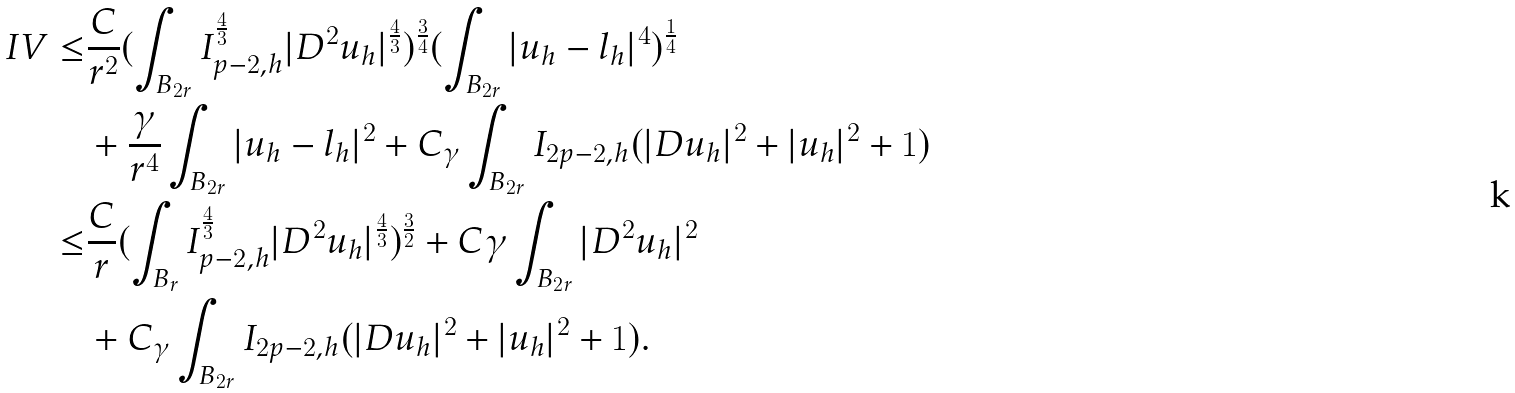<formula> <loc_0><loc_0><loc_500><loc_500>I V \leq & \frac { C } { r ^ { 2 } } ( \int _ { B _ { 2 r } } I _ { p - 2 , h } ^ { \frac { 4 } { 3 } } | D ^ { 2 } u _ { h } | ^ { \frac { 4 } { 3 } } ) ^ { \frac { 3 } { 4 } } ( \int _ { B _ { 2 r } } | u _ { h } - l _ { h } | ^ { 4 } ) ^ { \frac { 1 } { 4 } } \\ & + \frac { \gamma } { r ^ { 4 } } \int _ { B _ { 2 r } } | u _ { h } - l _ { h } | ^ { 2 } + C _ { \gamma } \int _ { B _ { 2 r } } I _ { 2 p - 2 , h } ( | D u _ { h } | ^ { 2 } + | u _ { h } | ^ { 2 } + 1 ) \\ \leq & \frac { C } { r } ( \int _ { B _ { r } } I _ { p - 2 , h } ^ { \frac { 4 } { 3 } } | D ^ { 2 } u _ { h } | ^ { \frac { 4 } { 3 } } ) ^ { \frac { 3 } { 2 } } + C \gamma \int _ { B _ { 2 r } } | D ^ { 2 } u _ { h } | ^ { 2 } \\ & + C _ { \gamma } \int _ { B _ { 2 r } } I _ { 2 p - 2 , h } ( | D u _ { h } | ^ { 2 } + | u _ { h } | ^ { 2 } + 1 ) .</formula> 